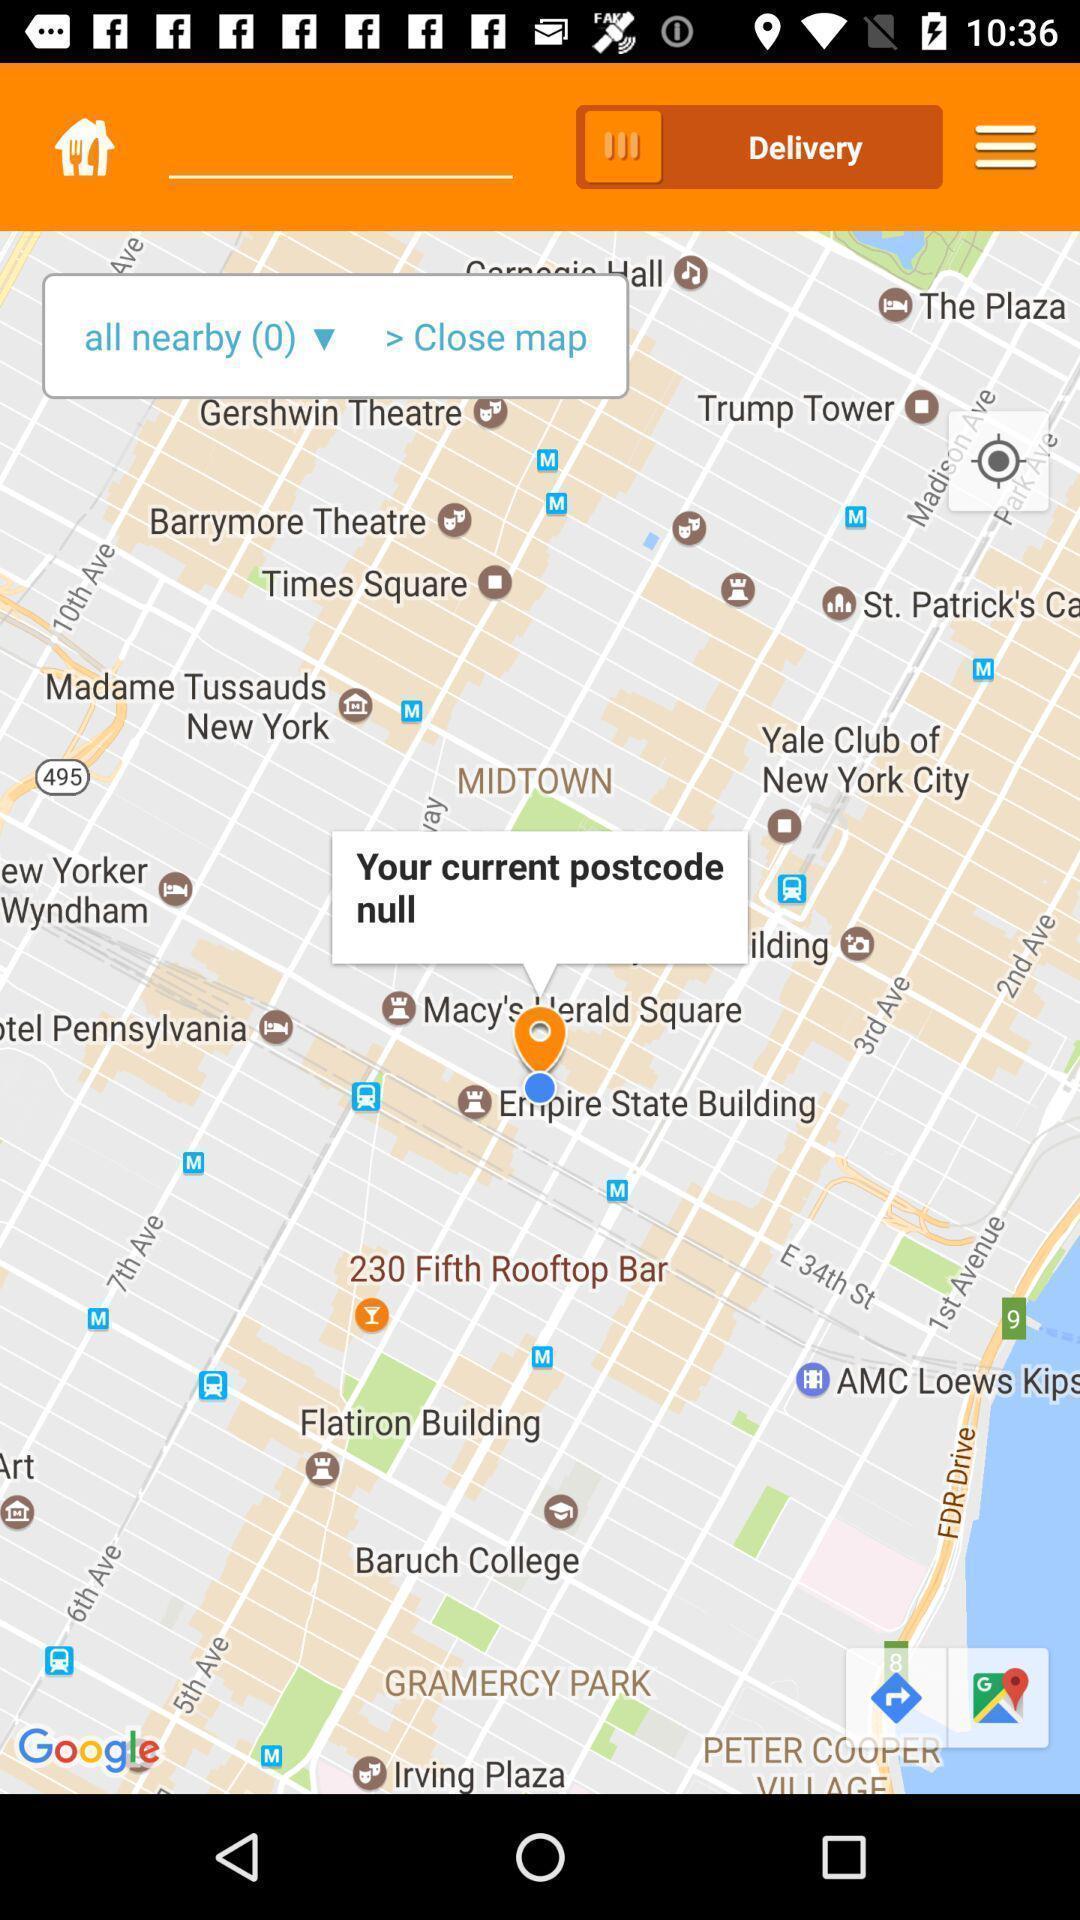Describe this image in words. Page that displaying gps application. 